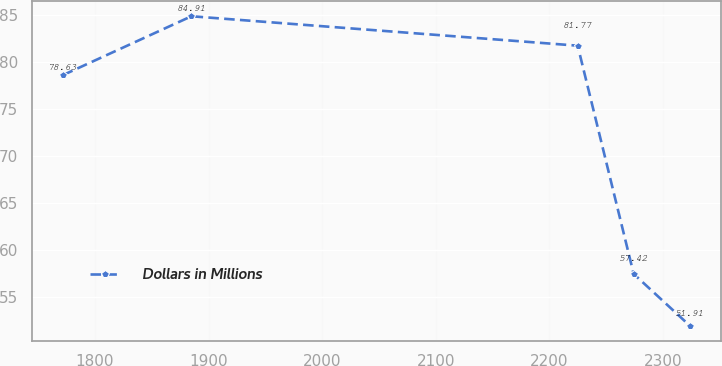Convert chart. <chart><loc_0><loc_0><loc_500><loc_500><line_chart><ecel><fcel>Dollars in Millions<nl><fcel>1771.77<fcel>78.63<nl><fcel>1884.93<fcel>84.91<nl><fcel>2225.09<fcel>81.77<nl><fcel>2274.4<fcel>57.42<nl><fcel>2323.71<fcel>51.91<nl></chart> 